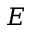<formula> <loc_0><loc_0><loc_500><loc_500>E</formula> 